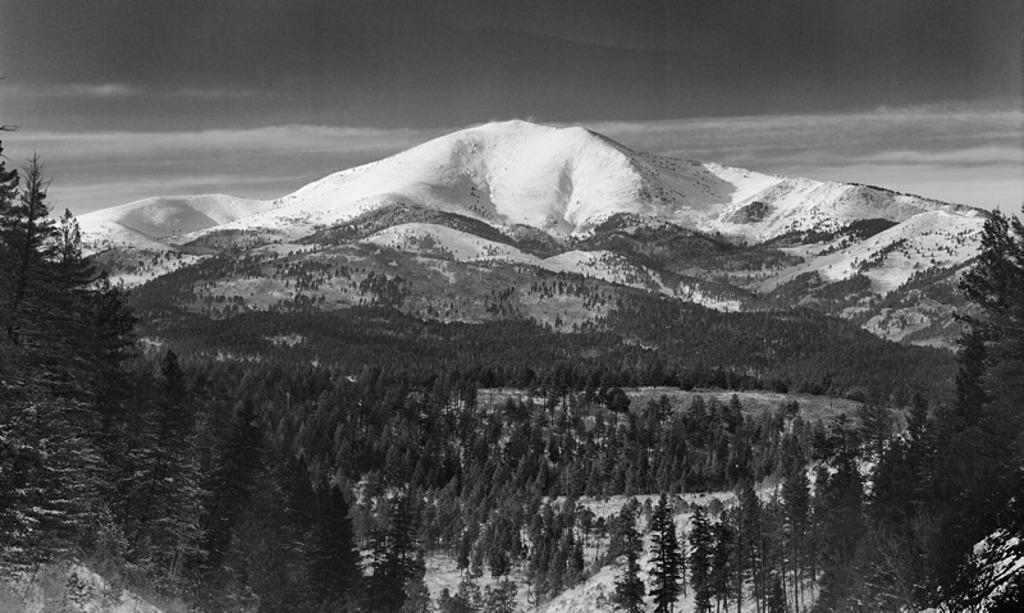What is the color scheme of the image? The image is black and white. What geographical feature can be seen in the image? There are mountains in the image. What is the condition of the mountains in the image? The mountains are covered with snow. What type of terrain is visible in the image? There is ground visible in the image. What type of vegetation is present in the image? There are trees in the image. Can you tell me what reason the mountains have for being in the image? The mountains are not in the image for a reason; they are a natural geographical feature that happens to be present in the scene. Is there a playground visible in the image? No, there is no playground present in the image. 